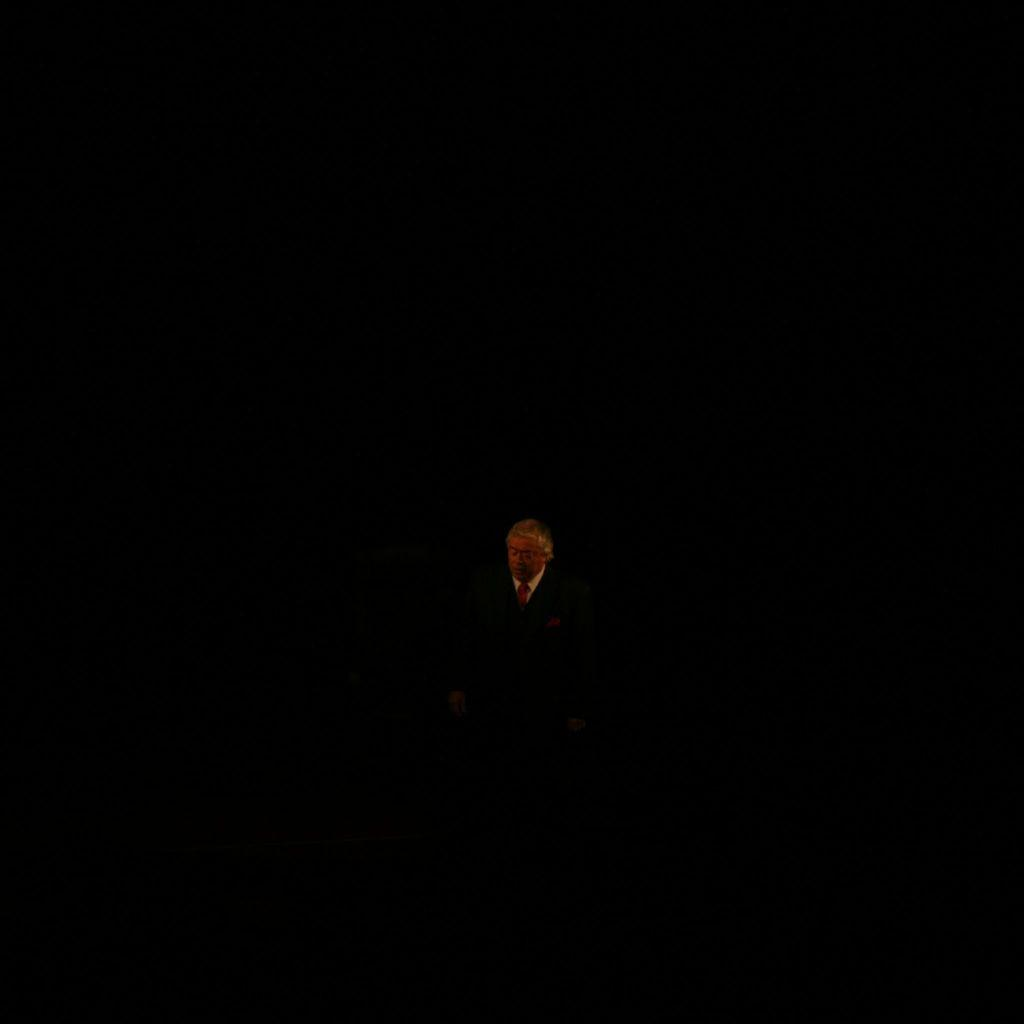What is the main subject of the image? There is a person standing in the center of the image. Can you describe the position of the person in the image? The person is standing in the center of the image. What might the person be doing in the image? It is not clear from the image what the person is doing, but they are standing in the center. What type of statement is the person making in the image? There is no indication in the image that the person is making any statement. 